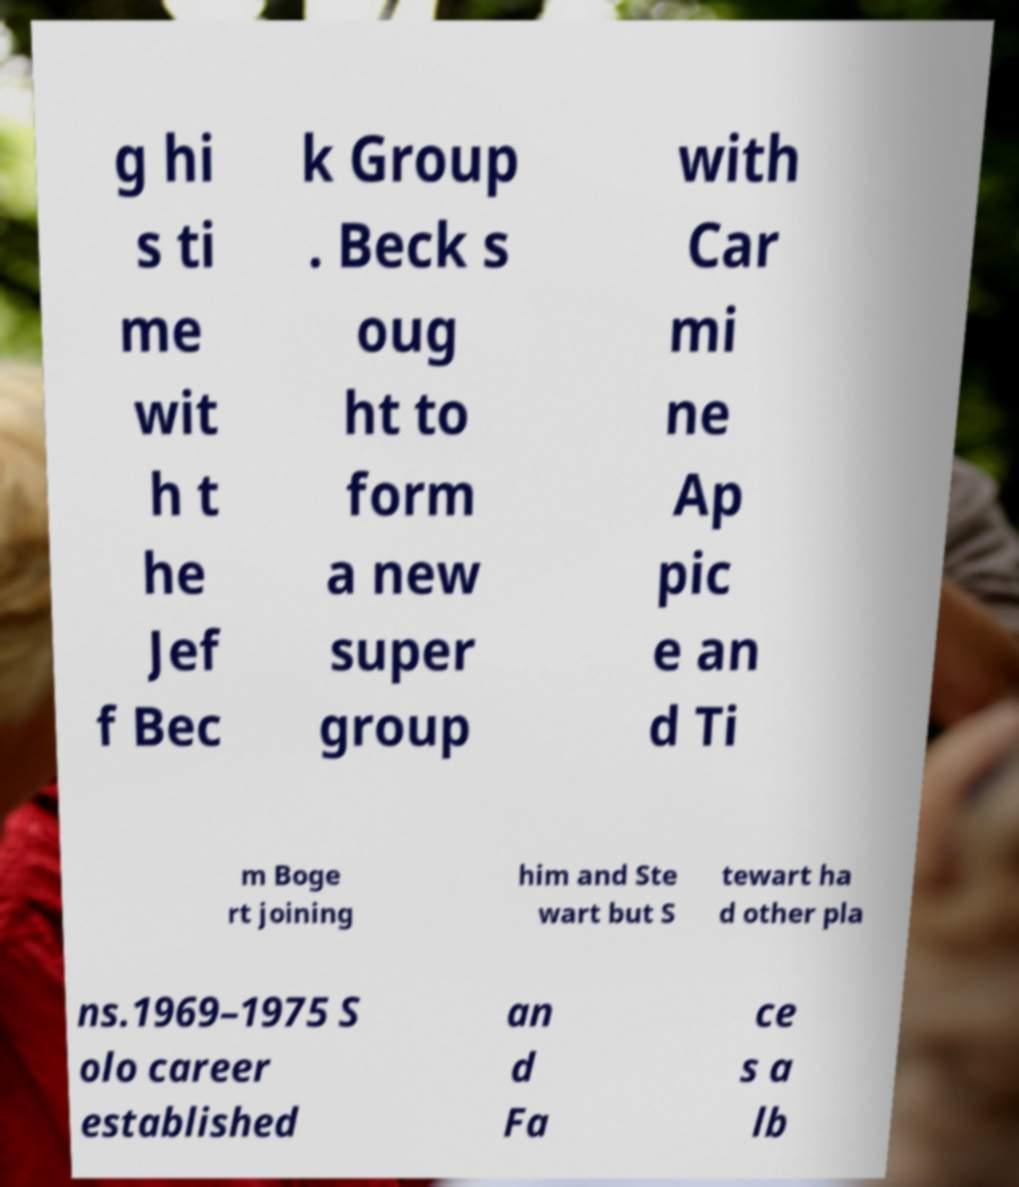Can you read and provide the text displayed in the image?This photo seems to have some interesting text. Can you extract and type it out for me? g hi s ti me wit h t he Jef f Bec k Group . Beck s oug ht to form a new super group with Car mi ne Ap pic e an d Ti m Boge rt joining him and Ste wart but S tewart ha d other pla ns.1969–1975 S olo career established an d Fa ce s a lb 